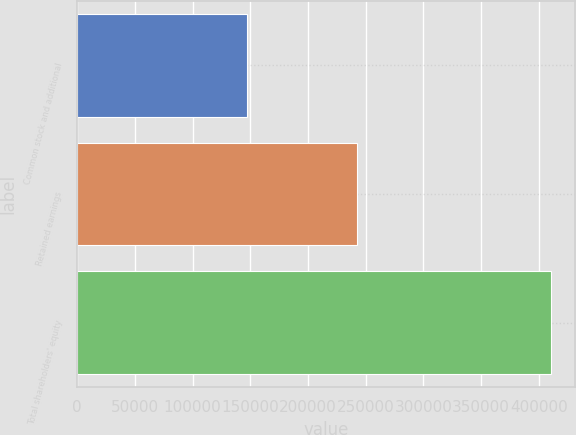Convert chart to OTSL. <chart><loc_0><loc_0><loc_500><loc_500><bar_chart><fcel>Common stock and additional<fcel>Retained earnings<fcel>Total shareholders' equity<nl><fcel>147395<fcel>242618<fcel>410352<nl></chart> 